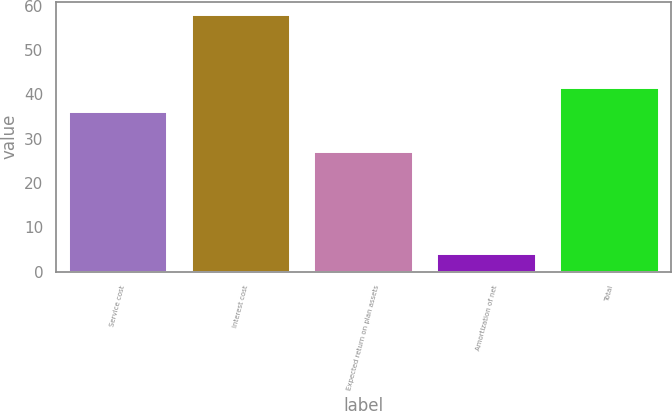<chart> <loc_0><loc_0><loc_500><loc_500><bar_chart><fcel>Service cost<fcel>Interest cost<fcel>Expected return on plan assets<fcel>Amortization of net<fcel>Total<nl><fcel>36<fcel>58<fcel>27<fcel>4<fcel>41.4<nl></chart> 